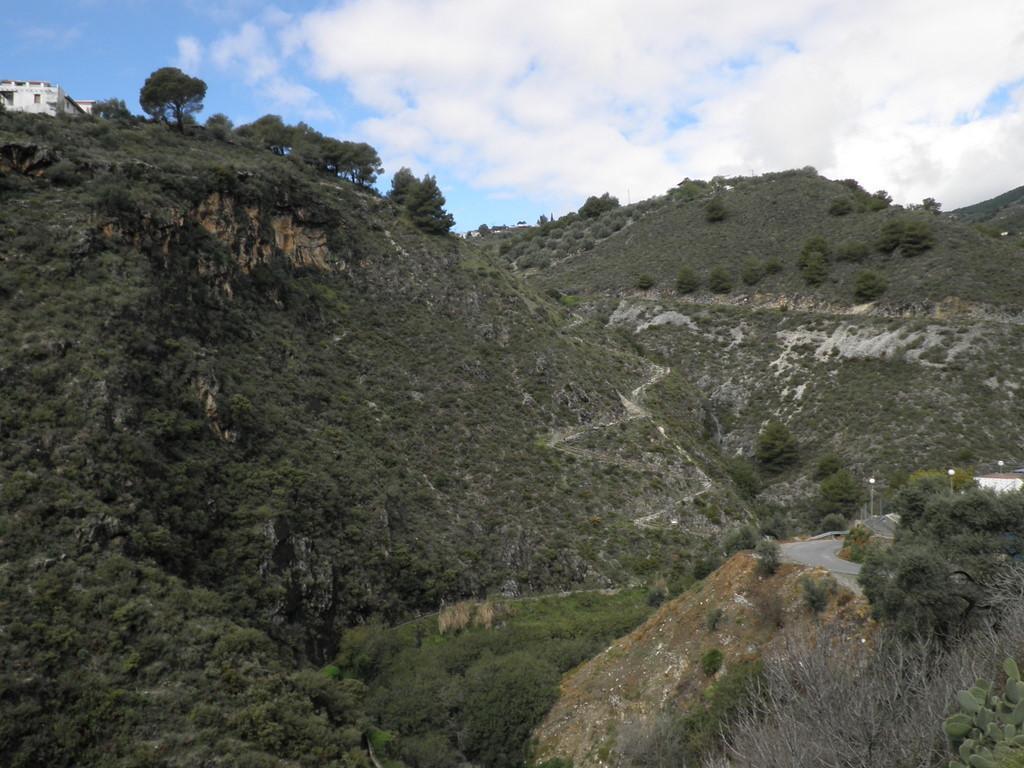How would you summarize this image in a sentence or two? in the given image i can see mountains which is build with trees and also i can see a road which includes three street lights , street poles including lights also i can see route. 